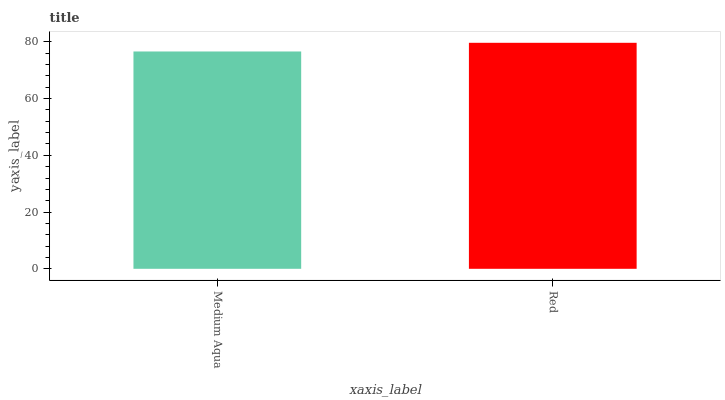Is Red the minimum?
Answer yes or no. No. Is Red greater than Medium Aqua?
Answer yes or no. Yes. Is Medium Aqua less than Red?
Answer yes or no. Yes. Is Medium Aqua greater than Red?
Answer yes or no. No. Is Red less than Medium Aqua?
Answer yes or no. No. Is Red the high median?
Answer yes or no. Yes. Is Medium Aqua the low median?
Answer yes or no. Yes. Is Medium Aqua the high median?
Answer yes or no. No. Is Red the low median?
Answer yes or no. No. 